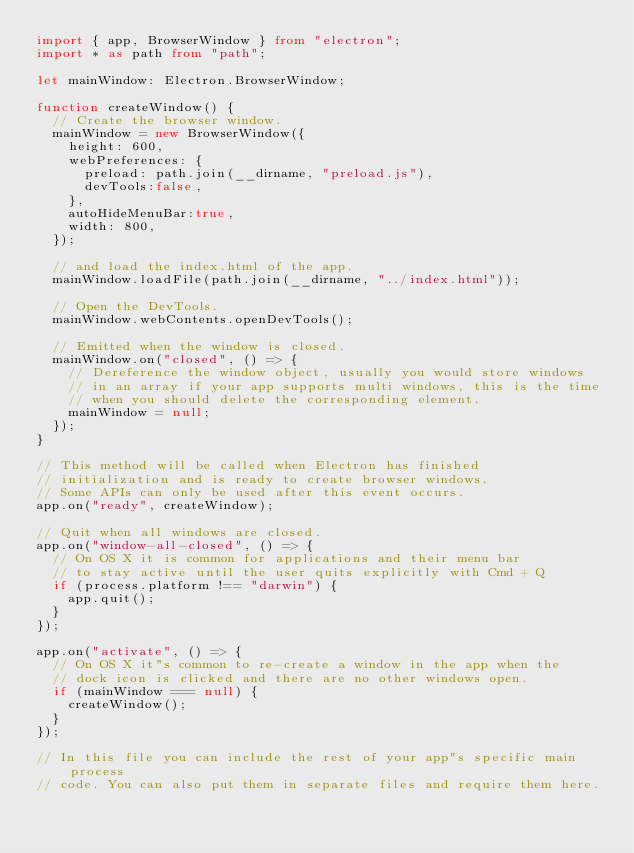Convert code to text. <code><loc_0><loc_0><loc_500><loc_500><_TypeScript_>import { app, BrowserWindow } from "electron";
import * as path from "path";

let mainWindow: Electron.BrowserWindow;

function createWindow() {
  // Create the browser window.
  mainWindow = new BrowserWindow({
    height: 600,
    webPreferences: {
      preload: path.join(__dirname, "preload.js"),
      devTools:false,
    },
    autoHideMenuBar:true,
    width: 800,
  });

  // and load the index.html of the app.
  mainWindow.loadFile(path.join(__dirname, "../index.html"));

  // Open the DevTools.
  mainWindow.webContents.openDevTools();

  // Emitted when the window is closed.
  mainWindow.on("closed", () => {
    // Dereference the window object, usually you would store windows
    // in an array if your app supports multi windows, this is the time
    // when you should delete the corresponding element.
    mainWindow = null;
  });
}

// This method will be called when Electron has finished
// initialization and is ready to create browser windows.
// Some APIs can only be used after this event occurs.
app.on("ready", createWindow);

// Quit when all windows are closed.
app.on("window-all-closed", () => {
  // On OS X it is common for applications and their menu bar
  // to stay active until the user quits explicitly with Cmd + Q
  if (process.platform !== "darwin") {
    app.quit();
  }
});

app.on("activate", () => {
  // On OS X it"s common to re-create a window in the app when the
  // dock icon is clicked and there are no other windows open.
  if (mainWindow === null) {
    createWindow();
  }
});

// In this file you can include the rest of your app"s specific main process
// code. You can also put them in separate files and require them here.
</code> 